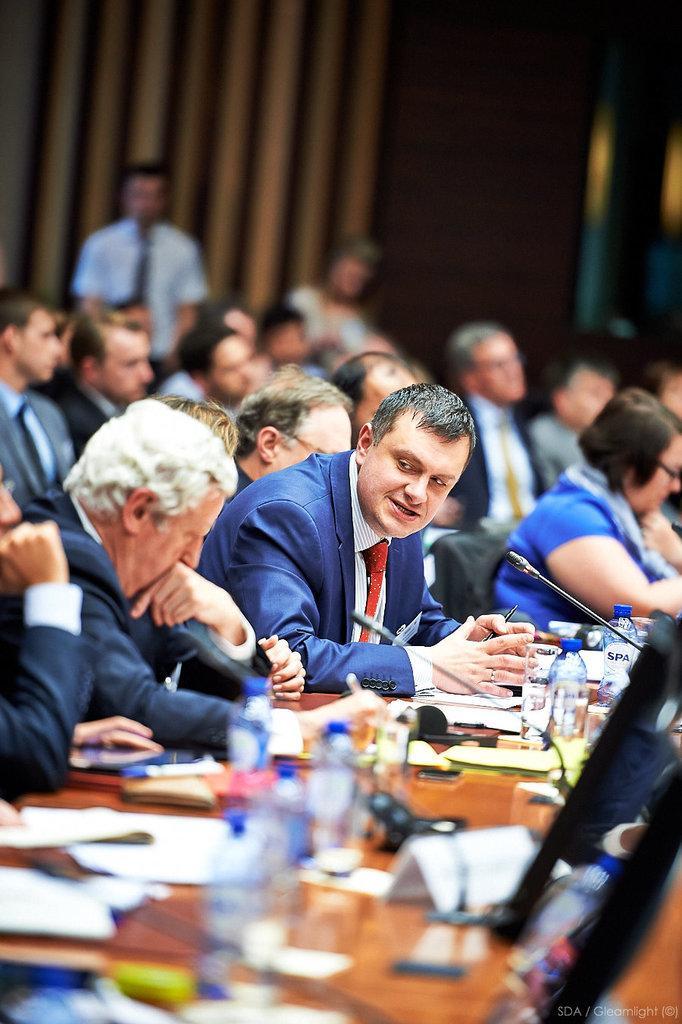How would you summarize this image in a sentence or two? At the bottom of the image on the table there are bottles, glasses, papers, name boards, mics and some other things on it. And there are many people sitting. Behind them there is a blur background. 